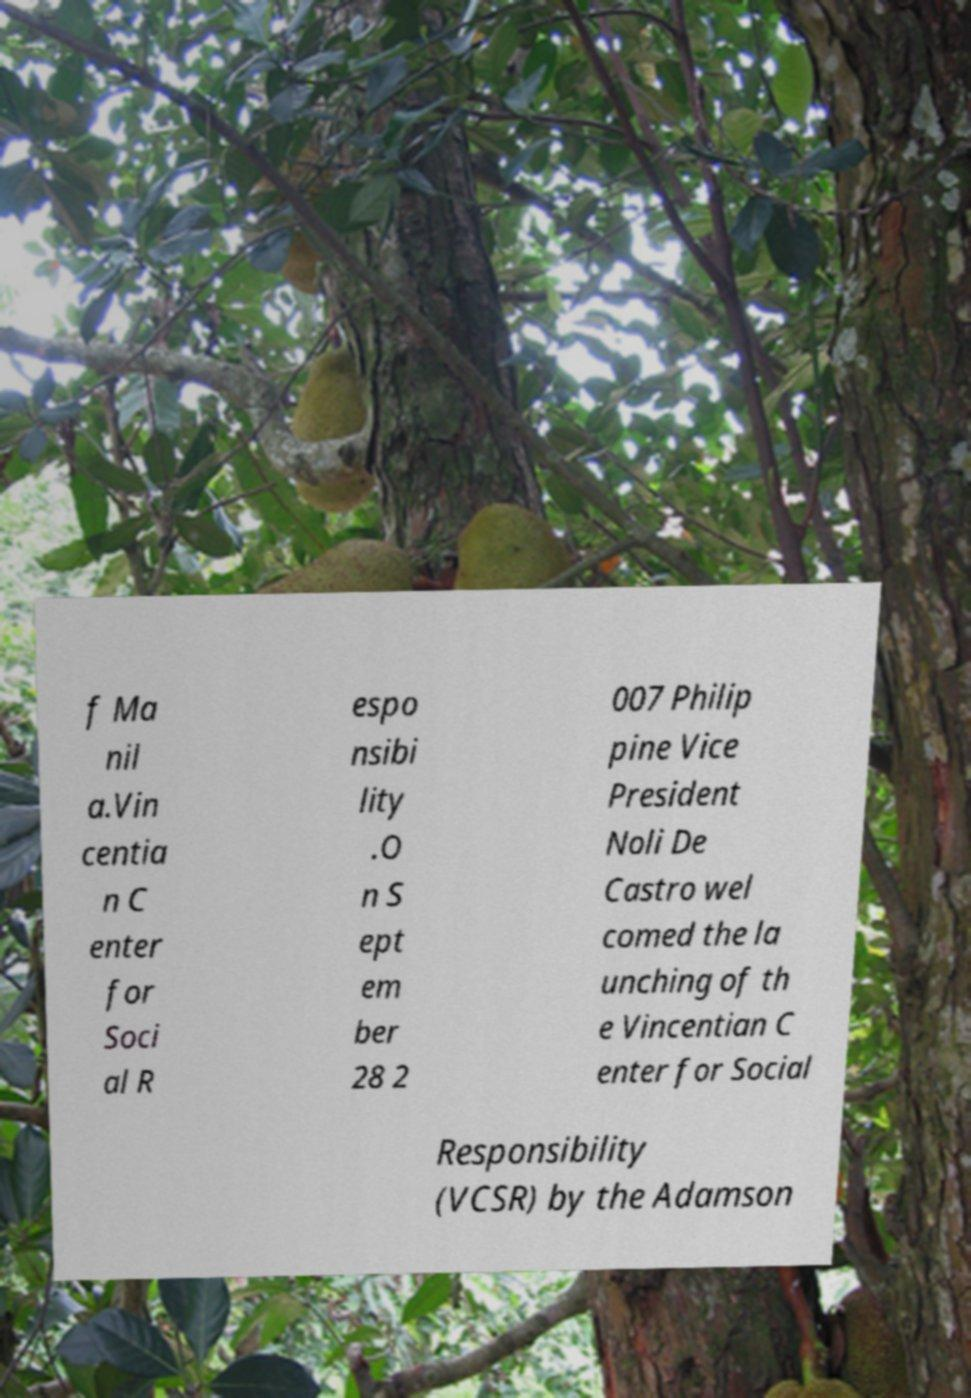For documentation purposes, I need the text within this image transcribed. Could you provide that? f Ma nil a.Vin centia n C enter for Soci al R espo nsibi lity .O n S ept em ber 28 2 007 Philip pine Vice President Noli De Castro wel comed the la unching of th e Vincentian C enter for Social Responsibility (VCSR) by the Adamson 